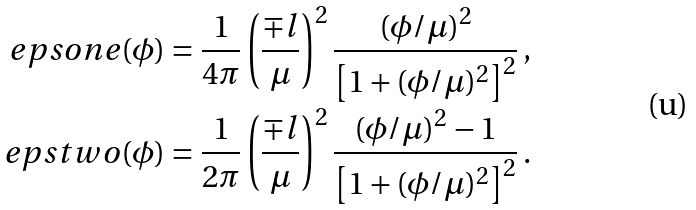Convert formula to latex. <formula><loc_0><loc_0><loc_500><loc_500>\ e p s o n e ( \phi ) & = \frac { 1 } { 4 \pi } \left ( \frac { \mp l } { \mu } \right ) ^ { 2 } \frac { ( \phi / \mu ) ^ { 2 } } { \left [ 1 + ( \phi / \mu ) ^ { 2 } \right ] ^ { 2 } } \, , \\ \ e p s t w o ( \phi ) & = \frac { 1 } { 2 \pi } \left ( \frac { \mp l } { \mu } \right ) ^ { 2 } \frac { ( \phi / \mu ) ^ { 2 } - 1 } { \left [ 1 + ( \phi / \mu ) ^ { 2 } \right ] ^ { 2 } } \, .</formula> 